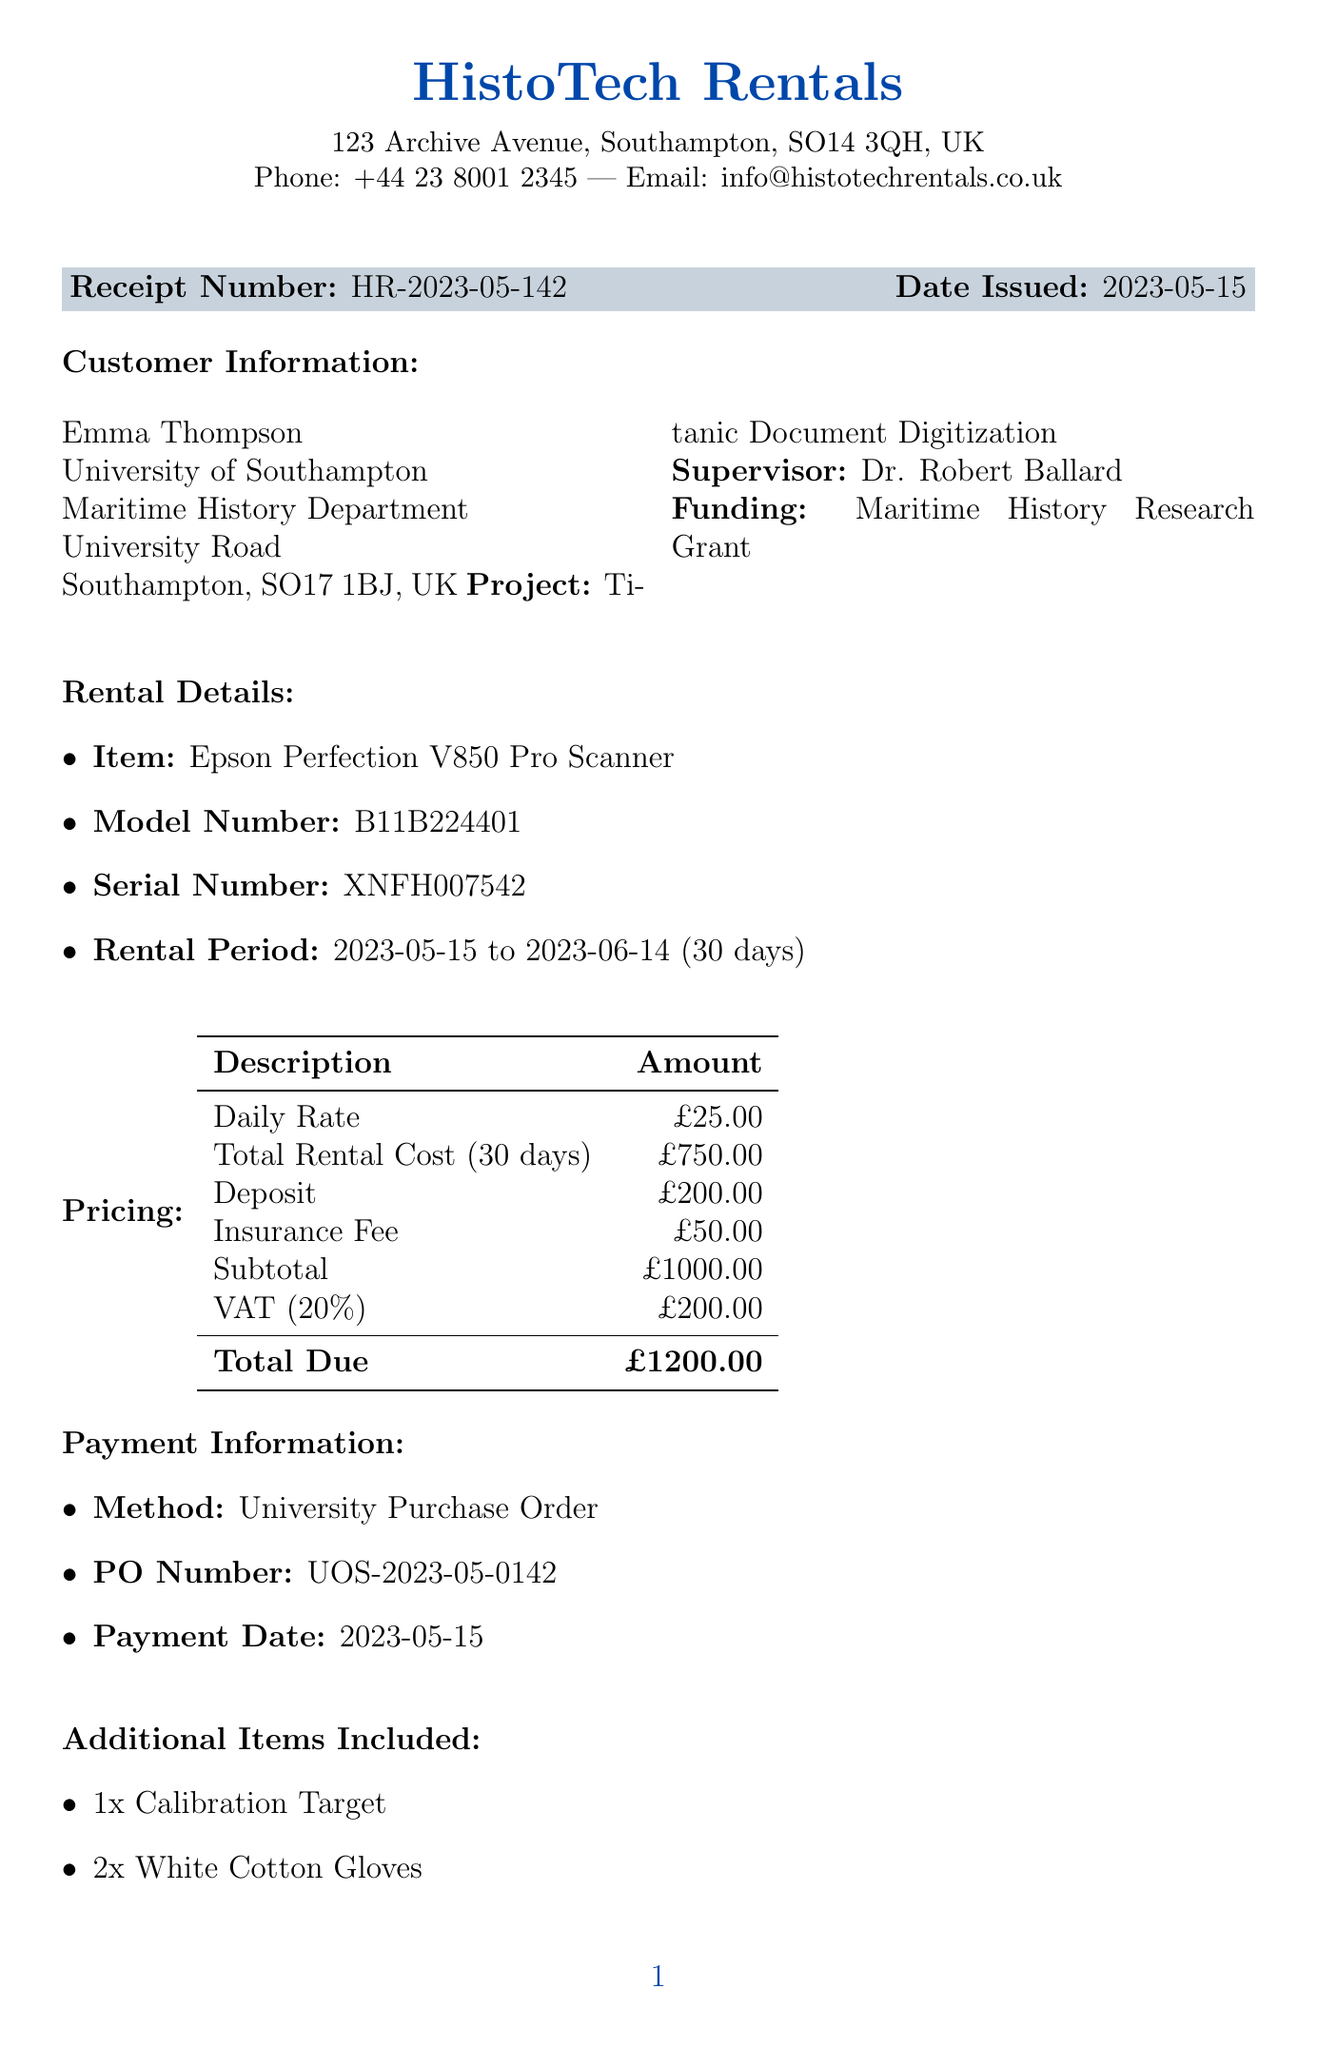What is the name of the rental company? The rental company is specified in the receipt header section.
Answer: HistoTech Rentals What is the rental period for the scanner? The rental period is mentioned in the rental details section.
Answer: 2023-05-15 to 2023-06-14 What is the total due amount? The total due is indicated in the pricing section of the receipt.
Answer: £1200.00 Who is the customer? The customer's name is provided in the customer information section of the receipt.
Answer: Emma Thompson What is the model number of the scanner? The model number is included in the rental details section.
Answer: B11B224401 What was the method of payment? The payment method is specified in the payment information section.
Answer: University Purchase Order What is included with the scanner rental? The additional items included help to identify what comes with the rental.
Answer: Calibration Target, White Cotton Gloves, Microfiber Cleaning Cloth What is the purpose of the rental? The purpose of the rental is stated in the rental purpose section.
Answer: High-resolution digitization of Titanic-era documents and photographs for archival preservation and research analysis What is the total VAT amount? The VAT amount is indicated in the pricing table.
Answer: £200.00 What are the terms regarding late returns? The terms and conditions section outlines the consequences of late returns.
Answer: Late returns will incur additional daily charges 